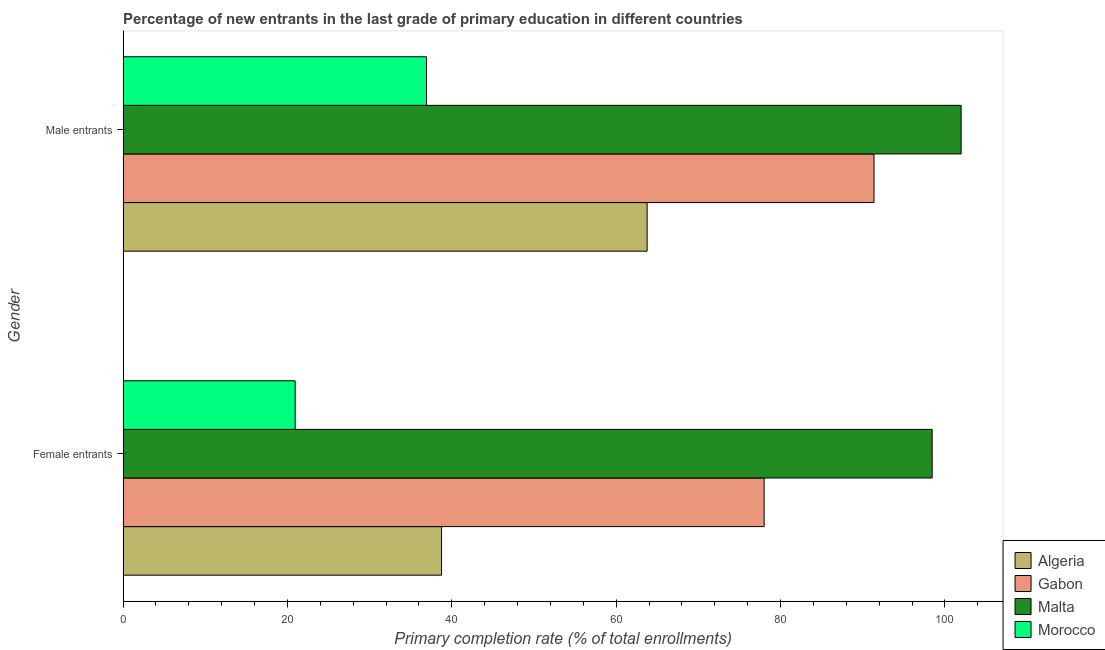How many different coloured bars are there?
Provide a succinct answer. 4. Are the number of bars per tick equal to the number of legend labels?
Your response must be concise. Yes. What is the label of the 2nd group of bars from the top?
Offer a very short reply. Female entrants. What is the primary completion rate of female entrants in Morocco?
Offer a very short reply. 20.95. Across all countries, what is the maximum primary completion rate of female entrants?
Make the answer very short. 98.45. Across all countries, what is the minimum primary completion rate of male entrants?
Give a very brief answer. 36.93. In which country was the primary completion rate of female entrants maximum?
Give a very brief answer. Malta. In which country was the primary completion rate of male entrants minimum?
Your response must be concise. Morocco. What is the total primary completion rate of male entrants in the graph?
Offer a terse response. 294.05. What is the difference between the primary completion rate of female entrants in Morocco and that in Algeria?
Your answer should be very brief. -17.81. What is the difference between the primary completion rate of female entrants in Algeria and the primary completion rate of male entrants in Morocco?
Your answer should be compact. 1.83. What is the average primary completion rate of male entrants per country?
Your response must be concise. 73.51. What is the difference between the primary completion rate of male entrants and primary completion rate of female entrants in Algeria?
Keep it short and to the point. 25.01. What is the ratio of the primary completion rate of male entrants in Algeria to that in Gabon?
Your answer should be very brief. 0.7. In how many countries, is the primary completion rate of male entrants greater than the average primary completion rate of male entrants taken over all countries?
Your answer should be very brief. 2. What does the 4th bar from the top in Female entrants represents?
Give a very brief answer. Algeria. What does the 1st bar from the bottom in Female entrants represents?
Your response must be concise. Algeria. How many bars are there?
Your response must be concise. 8. Are all the bars in the graph horizontal?
Offer a very short reply. Yes. How many countries are there in the graph?
Your answer should be very brief. 4. What is the difference between two consecutive major ticks on the X-axis?
Your answer should be very brief. 20. Are the values on the major ticks of X-axis written in scientific E-notation?
Ensure brevity in your answer.  No. Does the graph contain any zero values?
Ensure brevity in your answer.  No. Does the graph contain grids?
Give a very brief answer. No. How many legend labels are there?
Provide a succinct answer. 4. What is the title of the graph?
Your answer should be compact. Percentage of new entrants in the last grade of primary education in different countries. Does "Colombia" appear as one of the legend labels in the graph?
Offer a terse response. No. What is the label or title of the X-axis?
Offer a very short reply. Primary completion rate (% of total enrollments). What is the Primary completion rate (% of total enrollments) in Algeria in Female entrants?
Offer a very short reply. 38.76. What is the Primary completion rate (% of total enrollments) of Gabon in Female entrants?
Your answer should be compact. 78.01. What is the Primary completion rate (% of total enrollments) in Malta in Female entrants?
Provide a short and direct response. 98.45. What is the Primary completion rate (% of total enrollments) in Morocco in Female entrants?
Ensure brevity in your answer.  20.95. What is the Primary completion rate (% of total enrollments) of Algeria in Male entrants?
Keep it short and to the point. 63.77. What is the Primary completion rate (% of total enrollments) of Gabon in Male entrants?
Provide a short and direct response. 91.37. What is the Primary completion rate (% of total enrollments) of Malta in Male entrants?
Give a very brief answer. 101.98. What is the Primary completion rate (% of total enrollments) in Morocco in Male entrants?
Your response must be concise. 36.93. Across all Gender, what is the maximum Primary completion rate (% of total enrollments) in Algeria?
Offer a terse response. 63.77. Across all Gender, what is the maximum Primary completion rate (% of total enrollments) in Gabon?
Offer a very short reply. 91.37. Across all Gender, what is the maximum Primary completion rate (% of total enrollments) in Malta?
Keep it short and to the point. 101.98. Across all Gender, what is the maximum Primary completion rate (% of total enrollments) of Morocco?
Your answer should be very brief. 36.93. Across all Gender, what is the minimum Primary completion rate (% of total enrollments) of Algeria?
Offer a very short reply. 38.76. Across all Gender, what is the minimum Primary completion rate (% of total enrollments) of Gabon?
Offer a very short reply. 78.01. Across all Gender, what is the minimum Primary completion rate (% of total enrollments) in Malta?
Ensure brevity in your answer.  98.45. Across all Gender, what is the minimum Primary completion rate (% of total enrollments) of Morocco?
Offer a very short reply. 20.95. What is the total Primary completion rate (% of total enrollments) of Algeria in the graph?
Make the answer very short. 102.53. What is the total Primary completion rate (% of total enrollments) of Gabon in the graph?
Provide a short and direct response. 169.38. What is the total Primary completion rate (% of total enrollments) in Malta in the graph?
Keep it short and to the point. 200.42. What is the total Primary completion rate (% of total enrollments) in Morocco in the graph?
Make the answer very short. 57.87. What is the difference between the Primary completion rate (% of total enrollments) of Algeria in Female entrants and that in Male entrants?
Give a very brief answer. -25.01. What is the difference between the Primary completion rate (% of total enrollments) in Gabon in Female entrants and that in Male entrants?
Provide a short and direct response. -13.36. What is the difference between the Primary completion rate (% of total enrollments) in Malta in Female entrants and that in Male entrants?
Give a very brief answer. -3.53. What is the difference between the Primary completion rate (% of total enrollments) in Morocco in Female entrants and that in Male entrants?
Offer a very short reply. -15.98. What is the difference between the Primary completion rate (% of total enrollments) in Algeria in Female entrants and the Primary completion rate (% of total enrollments) in Gabon in Male entrants?
Ensure brevity in your answer.  -52.61. What is the difference between the Primary completion rate (% of total enrollments) of Algeria in Female entrants and the Primary completion rate (% of total enrollments) of Malta in Male entrants?
Make the answer very short. -63.22. What is the difference between the Primary completion rate (% of total enrollments) of Algeria in Female entrants and the Primary completion rate (% of total enrollments) of Morocco in Male entrants?
Give a very brief answer. 1.83. What is the difference between the Primary completion rate (% of total enrollments) of Gabon in Female entrants and the Primary completion rate (% of total enrollments) of Malta in Male entrants?
Your answer should be very brief. -23.97. What is the difference between the Primary completion rate (% of total enrollments) in Gabon in Female entrants and the Primary completion rate (% of total enrollments) in Morocco in Male entrants?
Ensure brevity in your answer.  41.08. What is the difference between the Primary completion rate (% of total enrollments) of Malta in Female entrants and the Primary completion rate (% of total enrollments) of Morocco in Male entrants?
Make the answer very short. 61.52. What is the average Primary completion rate (% of total enrollments) of Algeria per Gender?
Ensure brevity in your answer.  51.27. What is the average Primary completion rate (% of total enrollments) in Gabon per Gender?
Keep it short and to the point. 84.69. What is the average Primary completion rate (% of total enrollments) of Malta per Gender?
Offer a very short reply. 100.21. What is the average Primary completion rate (% of total enrollments) of Morocco per Gender?
Your answer should be compact. 28.94. What is the difference between the Primary completion rate (% of total enrollments) in Algeria and Primary completion rate (% of total enrollments) in Gabon in Female entrants?
Ensure brevity in your answer.  -39.25. What is the difference between the Primary completion rate (% of total enrollments) in Algeria and Primary completion rate (% of total enrollments) in Malta in Female entrants?
Ensure brevity in your answer.  -59.69. What is the difference between the Primary completion rate (% of total enrollments) in Algeria and Primary completion rate (% of total enrollments) in Morocco in Female entrants?
Give a very brief answer. 17.81. What is the difference between the Primary completion rate (% of total enrollments) of Gabon and Primary completion rate (% of total enrollments) of Malta in Female entrants?
Give a very brief answer. -20.44. What is the difference between the Primary completion rate (% of total enrollments) of Gabon and Primary completion rate (% of total enrollments) of Morocco in Female entrants?
Ensure brevity in your answer.  57.06. What is the difference between the Primary completion rate (% of total enrollments) in Malta and Primary completion rate (% of total enrollments) in Morocco in Female entrants?
Keep it short and to the point. 77.5. What is the difference between the Primary completion rate (% of total enrollments) of Algeria and Primary completion rate (% of total enrollments) of Gabon in Male entrants?
Offer a terse response. -27.6. What is the difference between the Primary completion rate (% of total enrollments) of Algeria and Primary completion rate (% of total enrollments) of Malta in Male entrants?
Ensure brevity in your answer.  -38.2. What is the difference between the Primary completion rate (% of total enrollments) of Algeria and Primary completion rate (% of total enrollments) of Morocco in Male entrants?
Make the answer very short. 26.84. What is the difference between the Primary completion rate (% of total enrollments) of Gabon and Primary completion rate (% of total enrollments) of Malta in Male entrants?
Ensure brevity in your answer.  -10.6. What is the difference between the Primary completion rate (% of total enrollments) of Gabon and Primary completion rate (% of total enrollments) of Morocco in Male entrants?
Offer a very short reply. 54.45. What is the difference between the Primary completion rate (% of total enrollments) of Malta and Primary completion rate (% of total enrollments) of Morocco in Male entrants?
Make the answer very short. 65.05. What is the ratio of the Primary completion rate (% of total enrollments) of Algeria in Female entrants to that in Male entrants?
Your answer should be very brief. 0.61. What is the ratio of the Primary completion rate (% of total enrollments) of Gabon in Female entrants to that in Male entrants?
Ensure brevity in your answer.  0.85. What is the ratio of the Primary completion rate (% of total enrollments) of Malta in Female entrants to that in Male entrants?
Offer a terse response. 0.97. What is the ratio of the Primary completion rate (% of total enrollments) of Morocco in Female entrants to that in Male entrants?
Your answer should be compact. 0.57. What is the difference between the highest and the second highest Primary completion rate (% of total enrollments) in Algeria?
Provide a succinct answer. 25.01. What is the difference between the highest and the second highest Primary completion rate (% of total enrollments) of Gabon?
Offer a terse response. 13.36. What is the difference between the highest and the second highest Primary completion rate (% of total enrollments) in Malta?
Ensure brevity in your answer.  3.53. What is the difference between the highest and the second highest Primary completion rate (% of total enrollments) in Morocco?
Make the answer very short. 15.98. What is the difference between the highest and the lowest Primary completion rate (% of total enrollments) in Algeria?
Make the answer very short. 25.01. What is the difference between the highest and the lowest Primary completion rate (% of total enrollments) of Gabon?
Give a very brief answer. 13.36. What is the difference between the highest and the lowest Primary completion rate (% of total enrollments) in Malta?
Provide a succinct answer. 3.53. What is the difference between the highest and the lowest Primary completion rate (% of total enrollments) in Morocco?
Give a very brief answer. 15.98. 